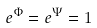Convert formula to latex. <formula><loc_0><loc_0><loc_500><loc_500>e ^ { \Phi } = e ^ { \Psi } = 1 \,</formula> 